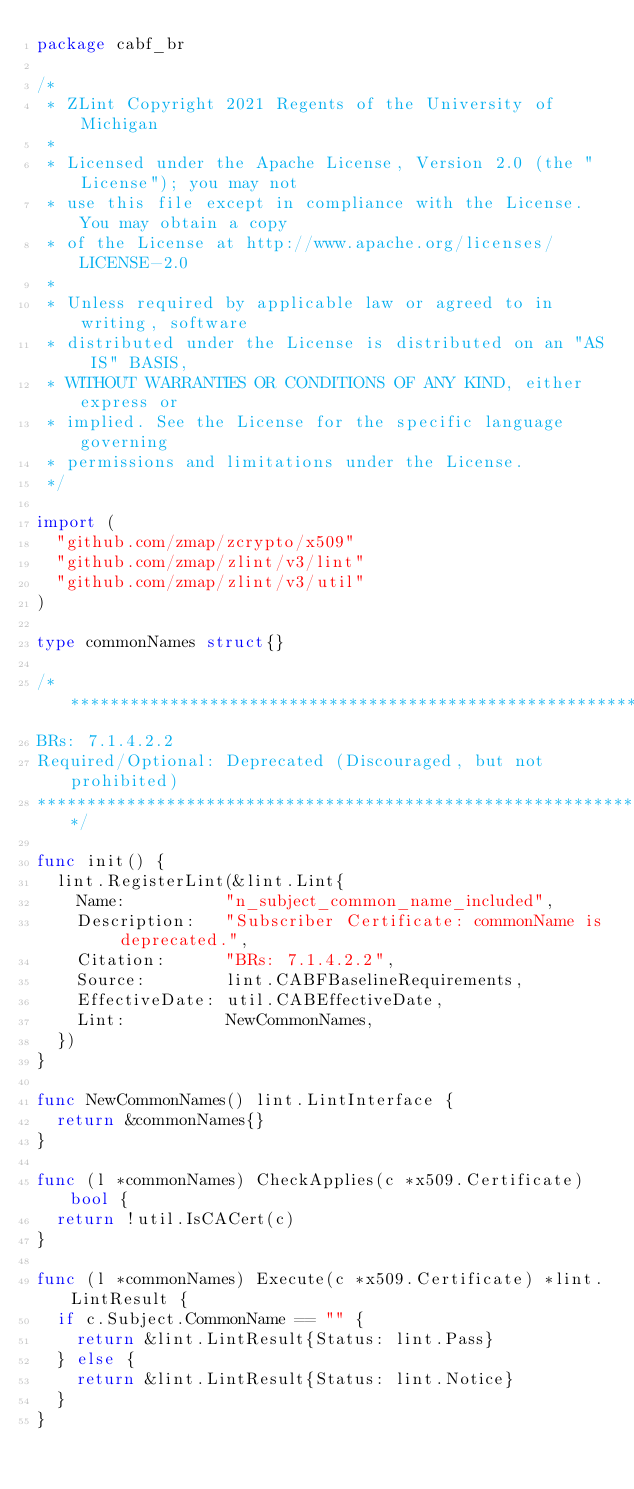<code> <loc_0><loc_0><loc_500><loc_500><_Go_>package cabf_br

/*
 * ZLint Copyright 2021 Regents of the University of Michigan
 *
 * Licensed under the Apache License, Version 2.0 (the "License"); you may not
 * use this file except in compliance with the License. You may obtain a copy
 * of the License at http://www.apache.org/licenses/LICENSE-2.0
 *
 * Unless required by applicable law or agreed to in writing, software
 * distributed under the License is distributed on an "AS IS" BASIS,
 * WITHOUT WARRANTIES OR CONDITIONS OF ANY KIND, either express or
 * implied. See the License for the specific language governing
 * permissions and limitations under the License.
 */

import (
	"github.com/zmap/zcrypto/x509"
	"github.com/zmap/zlint/v3/lint"
	"github.com/zmap/zlint/v3/util"
)

type commonNames struct{}

/***************************************************************
BRs: 7.1.4.2.2
Required/Optional: Deprecated (Discouraged, but not prohibited)
***************************************************************/

func init() {
	lint.RegisterLint(&lint.Lint{
		Name:          "n_subject_common_name_included",
		Description:   "Subscriber Certificate: commonName is deprecated.",
		Citation:      "BRs: 7.1.4.2.2",
		Source:        lint.CABFBaselineRequirements,
		EffectiveDate: util.CABEffectiveDate,
		Lint:          NewCommonNames,
	})
}

func NewCommonNames() lint.LintInterface {
	return &commonNames{}
}

func (l *commonNames) CheckApplies(c *x509.Certificate) bool {
	return !util.IsCACert(c)
}

func (l *commonNames) Execute(c *x509.Certificate) *lint.LintResult {
	if c.Subject.CommonName == "" {
		return &lint.LintResult{Status: lint.Pass}
	} else {
		return &lint.LintResult{Status: lint.Notice}
	}
}
</code> 